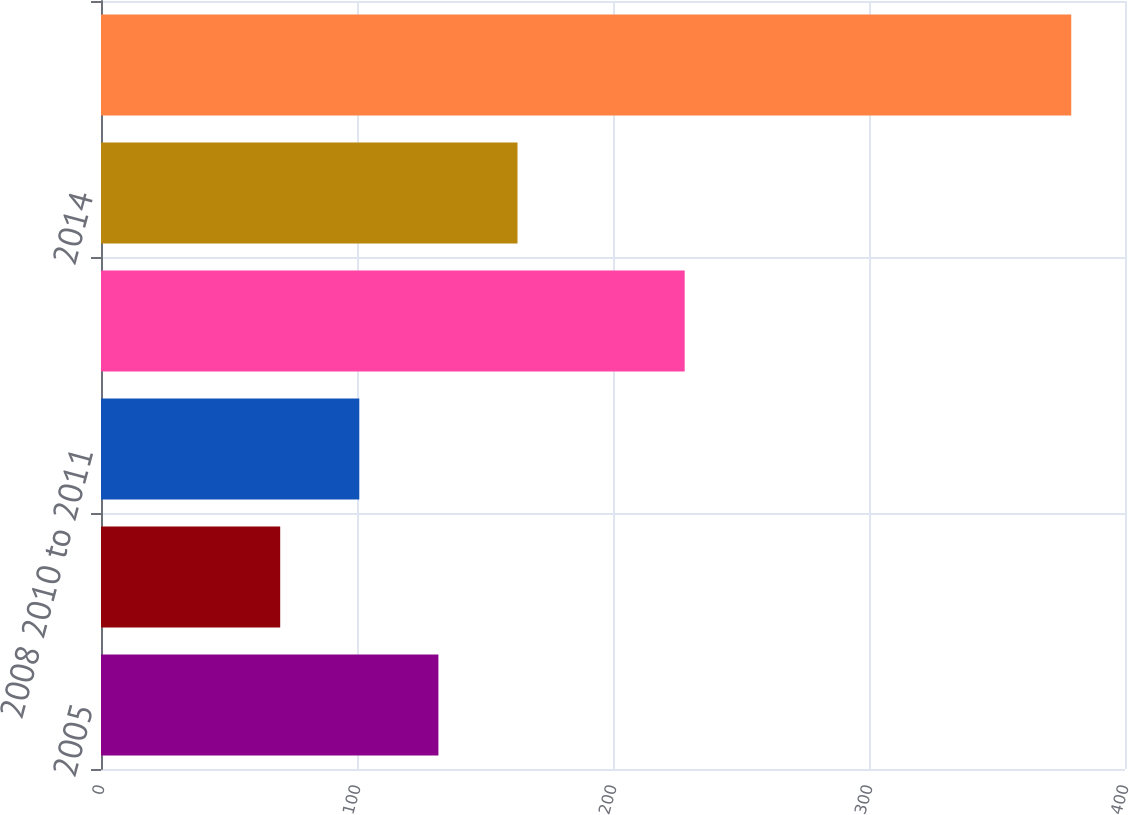Convert chart. <chart><loc_0><loc_0><loc_500><loc_500><bar_chart><fcel>2005<fcel>2007<fcel>2008 2010 to 2011<fcel>2013<fcel>2014<fcel>2016<nl><fcel>131.8<fcel>70<fcel>100.9<fcel>228<fcel>162.7<fcel>379<nl></chart> 